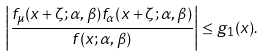Convert formula to latex. <formula><loc_0><loc_0><loc_500><loc_500>\left | \frac { f _ { \mu } ( x + \zeta ; \alpha , \beta ) f _ { \alpha } ( x + \zeta ; \alpha , \beta ) } { f ( x ; \alpha , \beta ) } \right | \leq g _ { 1 } ( x ) .</formula> 